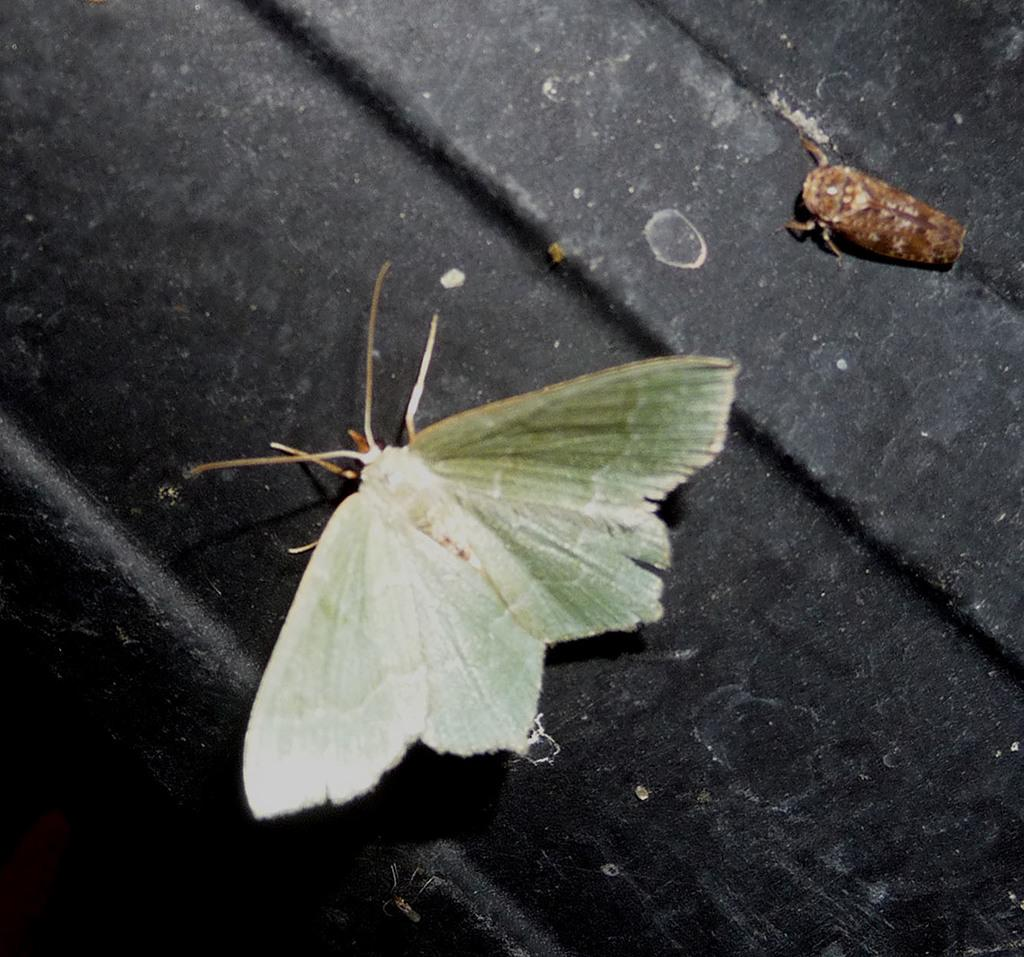What type of animal is present in the image? There is a moth in the image, which is a type of insect. What is the color of the surface in the image? The surface in the image is black. What advice does the grandfather give to the goat in the image? There is no grandfather or goat present in the image; it only features a moth and a black surface. 